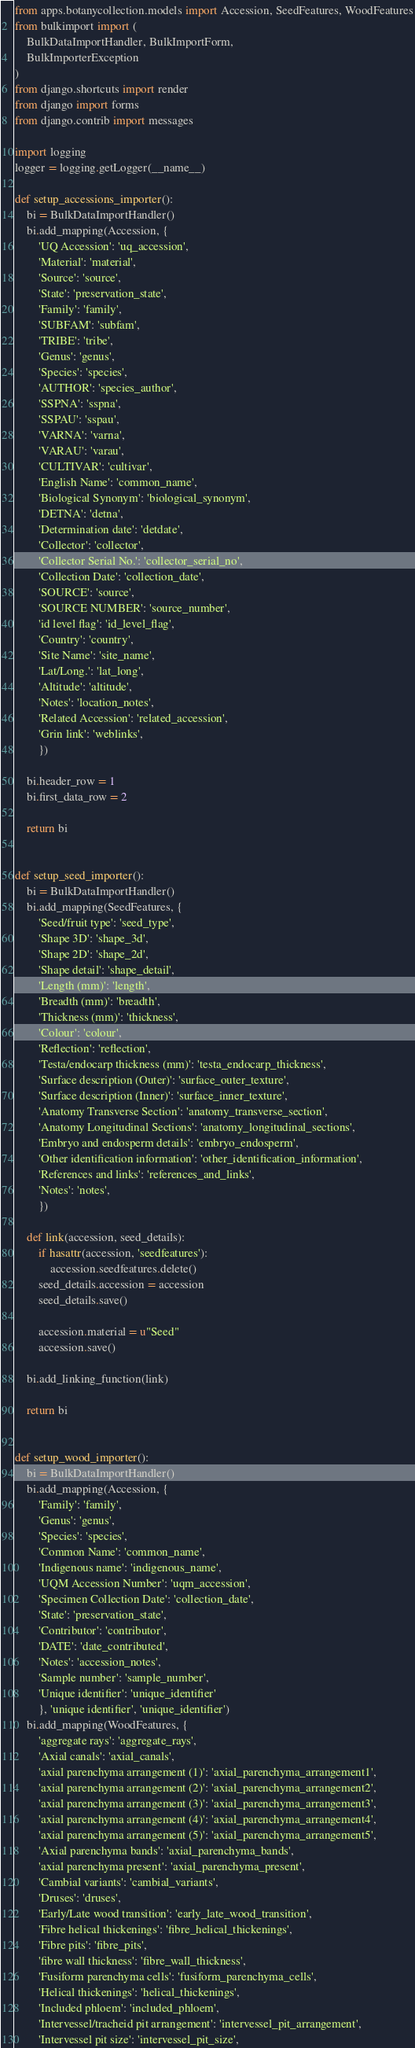Convert code to text. <code><loc_0><loc_0><loc_500><loc_500><_Python_>from apps.botanycollection.models import Accession, SeedFeatures, WoodFeatures
from bulkimport import (
	BulkDataImportHandler, BulkImportForm,
	BulkImporterException
)
from django.shortcuts import render
from django import forms
from django.contrib import messages

import logging
logger = logging.getLogger(__name__)

def setup_accessions_importer():
	bi = BulkDataImportHandler()
	bi.add_mapping(Accession, {
		'UQ Accession': 'uq_accession',
		'Material': 'material',
		'Source': 'source',
		'State': 'preservation_state',
		'Family': 'family',
		'SUBFAM': 'subfam',
		'TRIBE': 'tribe',
		'Genus': 'genus',
		'Species': 'species',
		'AUTHOR': 'species_author',
		'SSPNA': 'sspna',
		'SSPAU': 'sspau',
		'VARNA': 'varna',
		'VARAU': 'varau',
		'CULTIVAR': 'cultivar',
		'English Name': 'common_name',
		'Biological Synonym': 'biological_synonym',
		'DETNA': 'detna',
		'Determination date': 'detdate',
		'Collector': 'collector',
		'Collector Serial No.': 'collector_serial_no',
		'Collection Date': 'collection_date',
		'SOURCE': 'source',
		'SOURCE NUMBER': 'source_number',
		'id level flag': 'id_level_flag',
		'Country': 'country',
		'Site Name': 'site_name',
		'Lat/Long.': 'lat_long',
		'Altitude': 'altitude',
		'Notes': 'location_notes',
		'Related Accession': 'related_accession',
		'Grin link': 'weblinks',
		})

	bi.header_row = 1
	bi.first_data_row = 2

	return bi

	
def setup_seed_importer():
	bi = BulkDataImportHandler()
	bi.add_mapping(SeedFeatures, {
		'Seed/fruit type': 'seed_type',
		'Shape 3D': 'shape_3d',
		'Shape 2D': 'shape_2d',
		'Shape detail': 'shape_detail',
		'Length (mm)': 'length',
		'Breadth (mm)': 'breadth',
		'Thickness (mm)': 'thickness',
		'Colour': 'colour',
		'Reflection': 'reflection',
		'Testa/endocarp thickness (mm)': 'testa_endocarp_thickness',
		'Surface description (Outer)': 'surface_outer_texture',
		'Surface description (Inner)': 'surface_inner_texture',
		'Anatomy Transverse Section': 'anatomy_transverse_section',
		'Anatomy Longitudinal Sections': 'anatomy_longitudinal_sections',
		'Embryo and endosperm details': 'embryo_endosperm',
		'Other identification information': 'other_identification_information',
		'References and links': 'references_and_links',
		'Notes': 'notes',
		})

	def link(accession, seed_details):
		if hasattr(accession, 'seedfeatures'):
			accession.seedfeatures.delete()
		seed_details.accession = accession
		seed_details.save()

		accession.material = u"Seed"
		accession.save()

	bi.add_linking_function(link)

	return bi	
	

def setup_wood_importer():
	bi = BulkDataImportHandler()
	bi.add_mapping(Accession, {
		'Family': 'family',
		'Genus': 'genus',
		'Species': 'species',
		'Common Name': 'common_name',
		'Indigenous name': 'indigenous_name',
		'UQM Accession Number': 'uqm_accession',
		'Specimen Collection Date': 'collection_date',
		'State': 'preservation_state',
		'Contributor': 'contributor',
		'DATE': 'date_contributed',
		'Notes': 'accession_notes',
		'Sample number': 'sample_number',
		'Unique identifier': 'unique_identifier'
		}, 'unique identifier', 'unique_identifier')
	bi.add_mapping(WoodFeatures, {
		'aggregate rays': 'aggregate_rays',
		'Axial canals': 'axial_canals',
		'axial parenchyma arrangement (1)': 'axial_parenchyma_arrangement1',
		'axial parenchyma arrangement (2)': 'axial_parenchyma_arrangement2',
		'axial parenchyma arrangement (3)': 'axial_parenchyma_arrangement3',
		'axial parenchyma arrangement (4)': 'axial_parenchyma_arrangement4',
		'axial parenchyma arrangement (5)': 'axial_parenchyma_arrangement5',
		'Axial parenchyma bands': 'axial_parenchyma_bands',
		'axial parenchyma present': 'axial_parenchyma_present',
		'Cambial variants': 'cambial_variants',
		'Druses': 'druses',
		'Early/Late wood transition': 'early_late_wood_transition',
		'Fibre helical thickenings': 'fibre_helical_thickenings',
		'Fibre pits': 'fibre_pits',
		'fibre wall thickness': 'fibre_wall_thickness',
		'Fusiform parenchyma cells': 'fusiform_parenchyma_cells',
		'Helical thickenings': 'helical_thickenings',
		'Included phloem': 'included_phloem',
		'Intervessel/tracheid pit arrangement': 'intervessel_pit_arrangement',
		'Intervessel pit size': 'intervessel_pit_size',</code> 